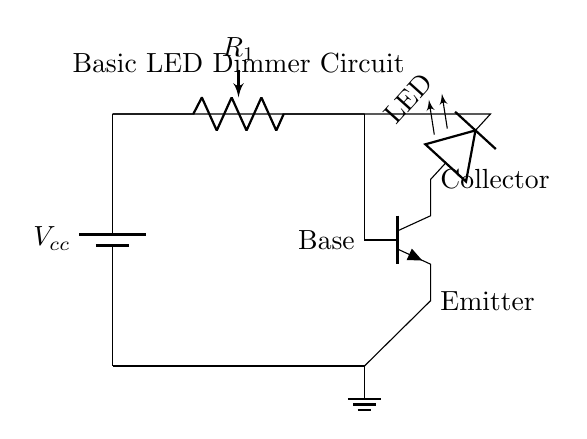What is the main purpose of this circuit? The main purpose of this circuit is to control the brightness of an LED by adjusting the resistance using a potentiometer, which varies the current through the LED.
Answer: LED dimming What component is used to adjust brightness? A potentiometer is used in the circuit to adjust brightness by changing its resistance, impacting the current flowing to the LED.
Answer: Potentiometer What is the function of the transistor in this circuit? The transistor acts as a switch or amplifier, controlling the current flow to the LED based on the input voltage from the potentiometer connected to its base.
Answer: Switch How many main components are in the circuit? The circuit has four main components: a battery, a potentiometer, a transistor, and an LED.
Answer: Four What is the role of the emitter in the transistor? The emitter allows current to flow out of the transistor, completing the circuit when the transistor is turned on by the base current from the potentiometer.
Answer: Current flow What connection is made to the transistor's collector? The collector is connected to the anode of the LED, allowing the LED to receive current from the battery when the transistor is activated.
Answer: LED anode 